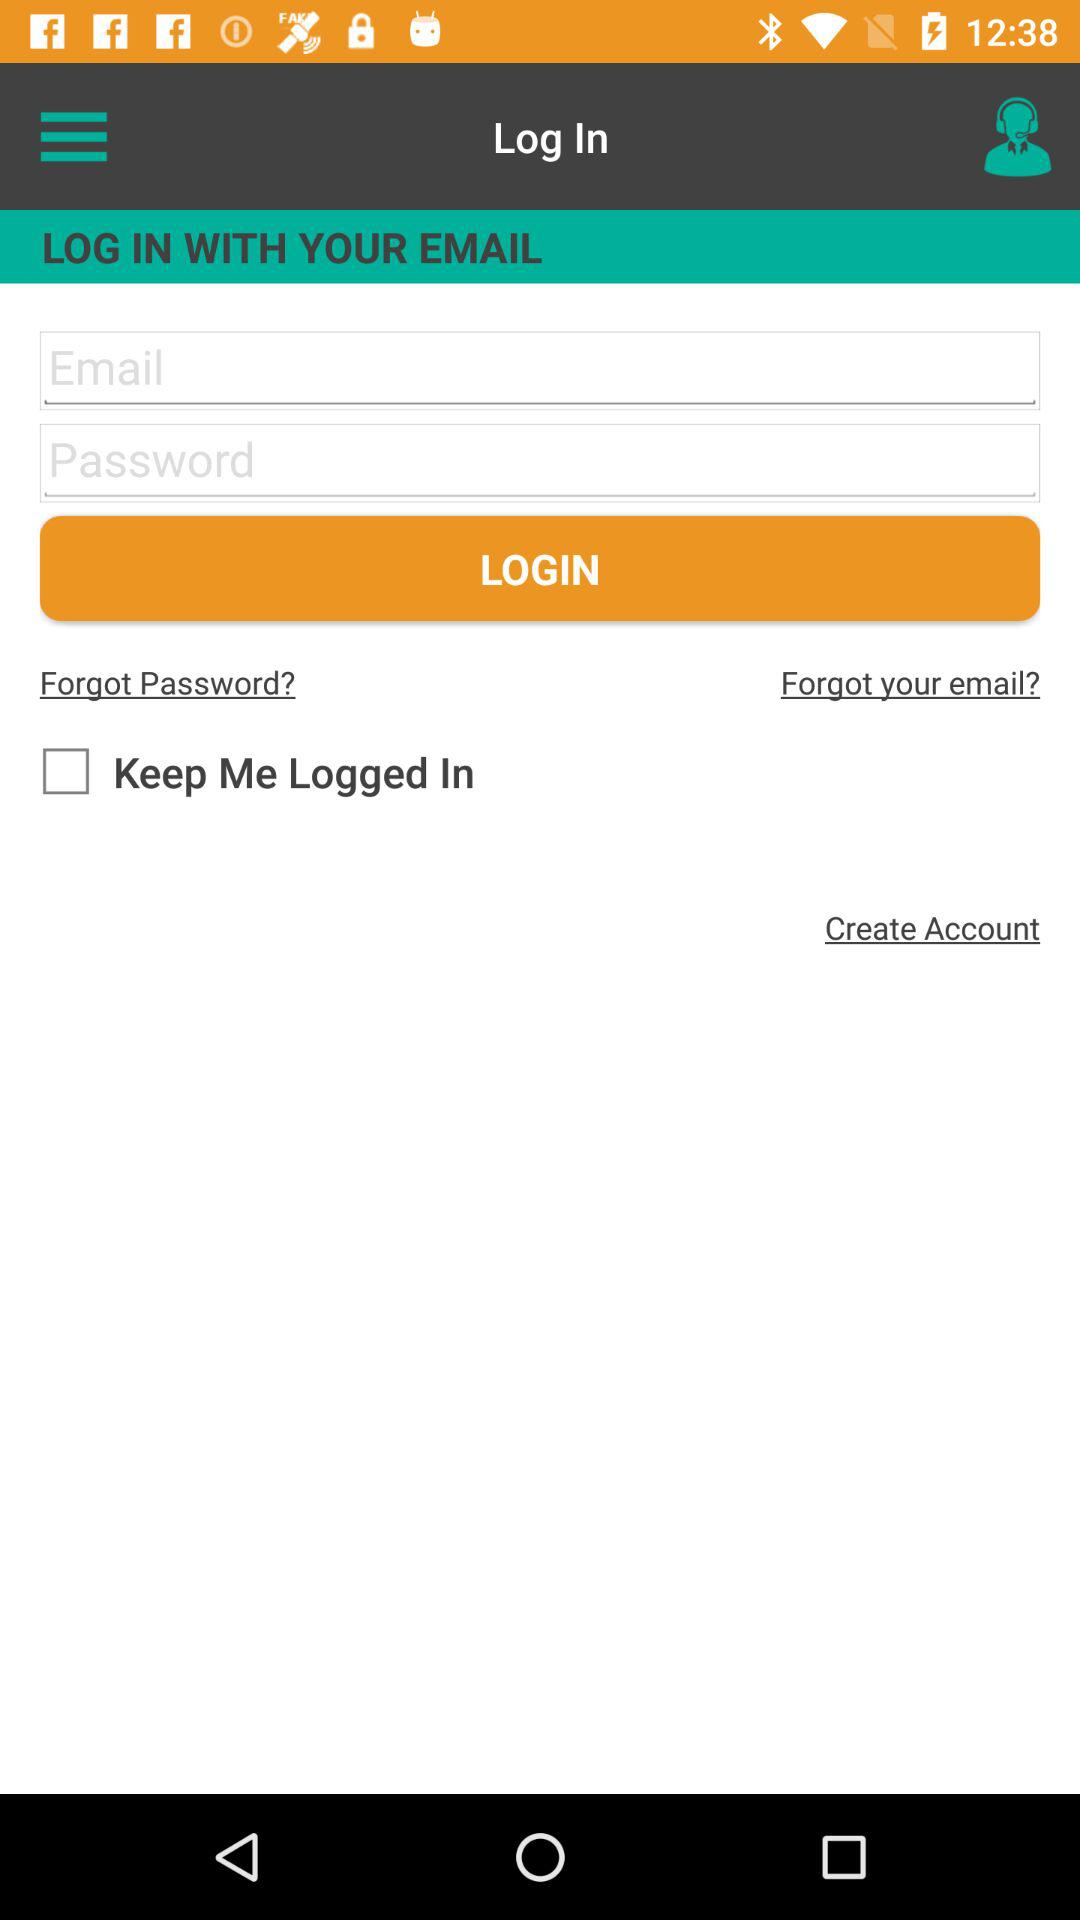Can we reset password?
When the provided information is insufficient, respond with <no answer>. <no answer> 